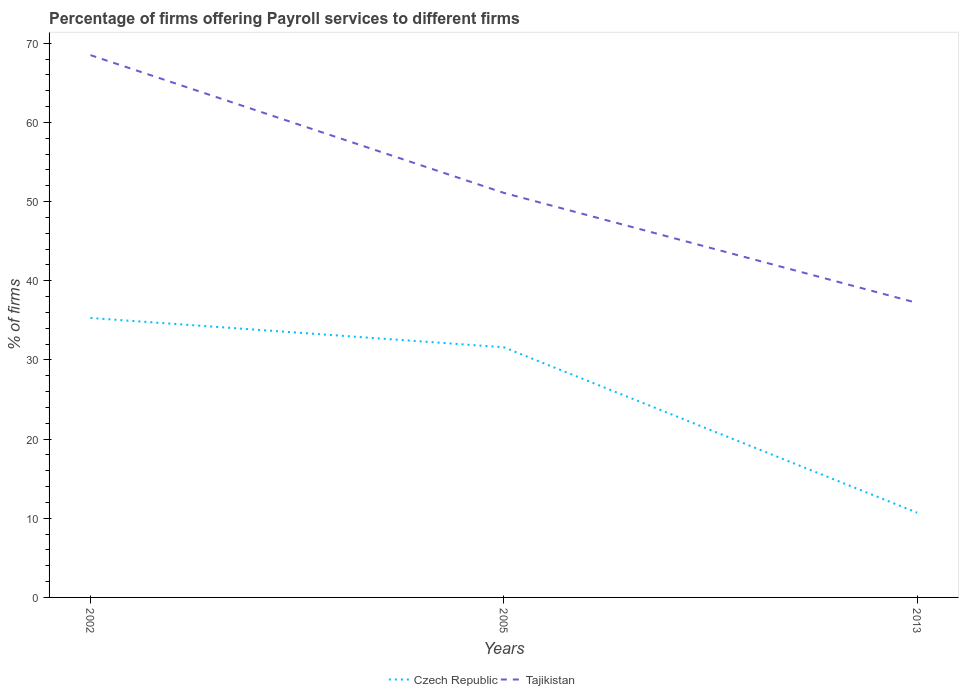Does the line corresponding to Czech Republic intersect with the line corresponding to Tajikistan?
Provide a succinct answer. No. Is the number of lines equal to the number of legend labels?
Give a very brief answer. Yes. Across all years, what is the maximum percentage of firms offering payroll services in Tajikistan?
Offer a terse response. 37.2. In which year was the percentage of firms offering payroll services in Czech Republic maximum?
Offer a very short reply. 2013. What is the total percentage of firms offering payroll services in Czech Republic in the graph?
Your response must be concise. 24.6. What is the difference between the highest and the second highest percentage of firms offering payroll services in Tajikistan?
Keep it short and to the point. 31.3. How many lines are there?
Your answer should be very brief. 2. How many years are there in the graph?
Offer a very short reply. 3. What is the difference between two consecutive major ticks on the Y-axis?
Ensure brevity in your answer.  10. Does the graph contain any zero values?
Ensure brevity in your answer.  No. What is the title of the graph?
Offer a very short reply. Percentage of firms offering Payroll services to different firms. What is the label or title of the Y-axis?
Offer a terse response. % of firms. What is the % of firms of Czech Republic in 2002?
Give a very brief answer. 35.3. What is the % of firms of Tajikistan in 2002?
Keep it short and to the point. 68.5. What is the % of firms of Czech Republic in 2005?
Make the answer very short. 31.6. What is the % of firms of Tajikistan in 2005?
Your response must be concise. 51.1. What is the % of firms in Czech Republic in 2013?
Provide a succinct answer. 10.7. What is the % of firms of Tajikistan in 2013?
Offer a very short reply. 37.2. Across all years, what is the maximum % of firms in Czech Republic?
Offer a very short reply. 35.3. Across all years, what is the maximum % of firms in Tajikistan?
Your answer should be very brief. 68.5. Across all years, what is the minimum % of firms in Czech Republic?
Your answer should be compact. 10.7. Across all years, what is the minimum % of firms of Tajikistan?
Your answer should be very brief. 37.2. What is the total % of firms in Czech Republic in the graph?
Keep it short and to the point. 77.6. What is the total % of firms in Tajikistan in the graph?
Ensure brevity in your answer.  156.8. What is the difference between the % of firms of Tajikistan in 2002 and that in 2005?
Give a very brief answer. 17.4. What is the difference between the % of firms in Czech Republic in 2002 and that in 2013?
Your answer should be very brief. 24.6. What is the difference between the % of firms in Tajikistan in 2002 and that in 2013?
Offer a very short reply. 31.3. What is the difference between the % of firms of Czech Republic in 2005 and that in 2013?
Provide a succinct answer. 20.9. What is the difference between the % of firms of Tajikistan in 2005 and that in 2013?
Offer a very short reply. 13.9. What is the difference between the % of firms in Czech Republic in 2002 and the % of firms in Tajikistan in 2005?
Offer a very short reply. -15.8. What is the average % of firms in Czech Republic per year?
Provide a short and direct response. 25.87. What is the average % of firms of Tajikistan per year?
Your response must be concise. 52.27. In the year 2002, what is the difference between the % of firms in Czech Republic and % of firms in Tajikistan?
Your answer should be very brief. -33.2. In the year 2005, what is the difference between the % of firms in Czech Republic and % of firms in Tajikistan?
Offer a terse response. -19.5. In the year 2013, what is the difference between the % of firms of Czech Republic and % of firms of Tajikistan?
Your response must be concise. -26.5. What is the ratio of the % of firms in Czech Republic in 2002 to that in 2005?
Provide a succinct answer. 1.12. What is the ratio of the % of firms of Tajikistan in 2002 to that in 2005?
Give a very brief answer. 1.34. What is the ratio of the % of firms in Czech Republic in 2002 to that in 2013?
Your answer should be compact. 3.3. What is the ratio of the % of firms of Tajikistan in 2002 to that in 2013?
Provide a succinct answer. 1.84. What is the ratio of the % of firms in Czech Republic in 2005 to that in 2013?
Your response must be concise. 2.95. What is the ratio of the % of firms in Tajikistan in 2005 to that in 2013?
Give a very brief answer. 1.37. What is the difference between the highest and the second highest % of firms in Czech Republic?
Your answer should be very brief. 3.7. What is the difference between the highest and the second highest % of firms of Tajikistan?
Make the answer very short. 17.4. What is the difference between the highest and the lowest % of firms of Czech Republic?
Your answer should be compact. 24.6. What is the difference between the highest and the lowest % of firms of Tajikistan?
Your answer should be very brief. 31.3. 